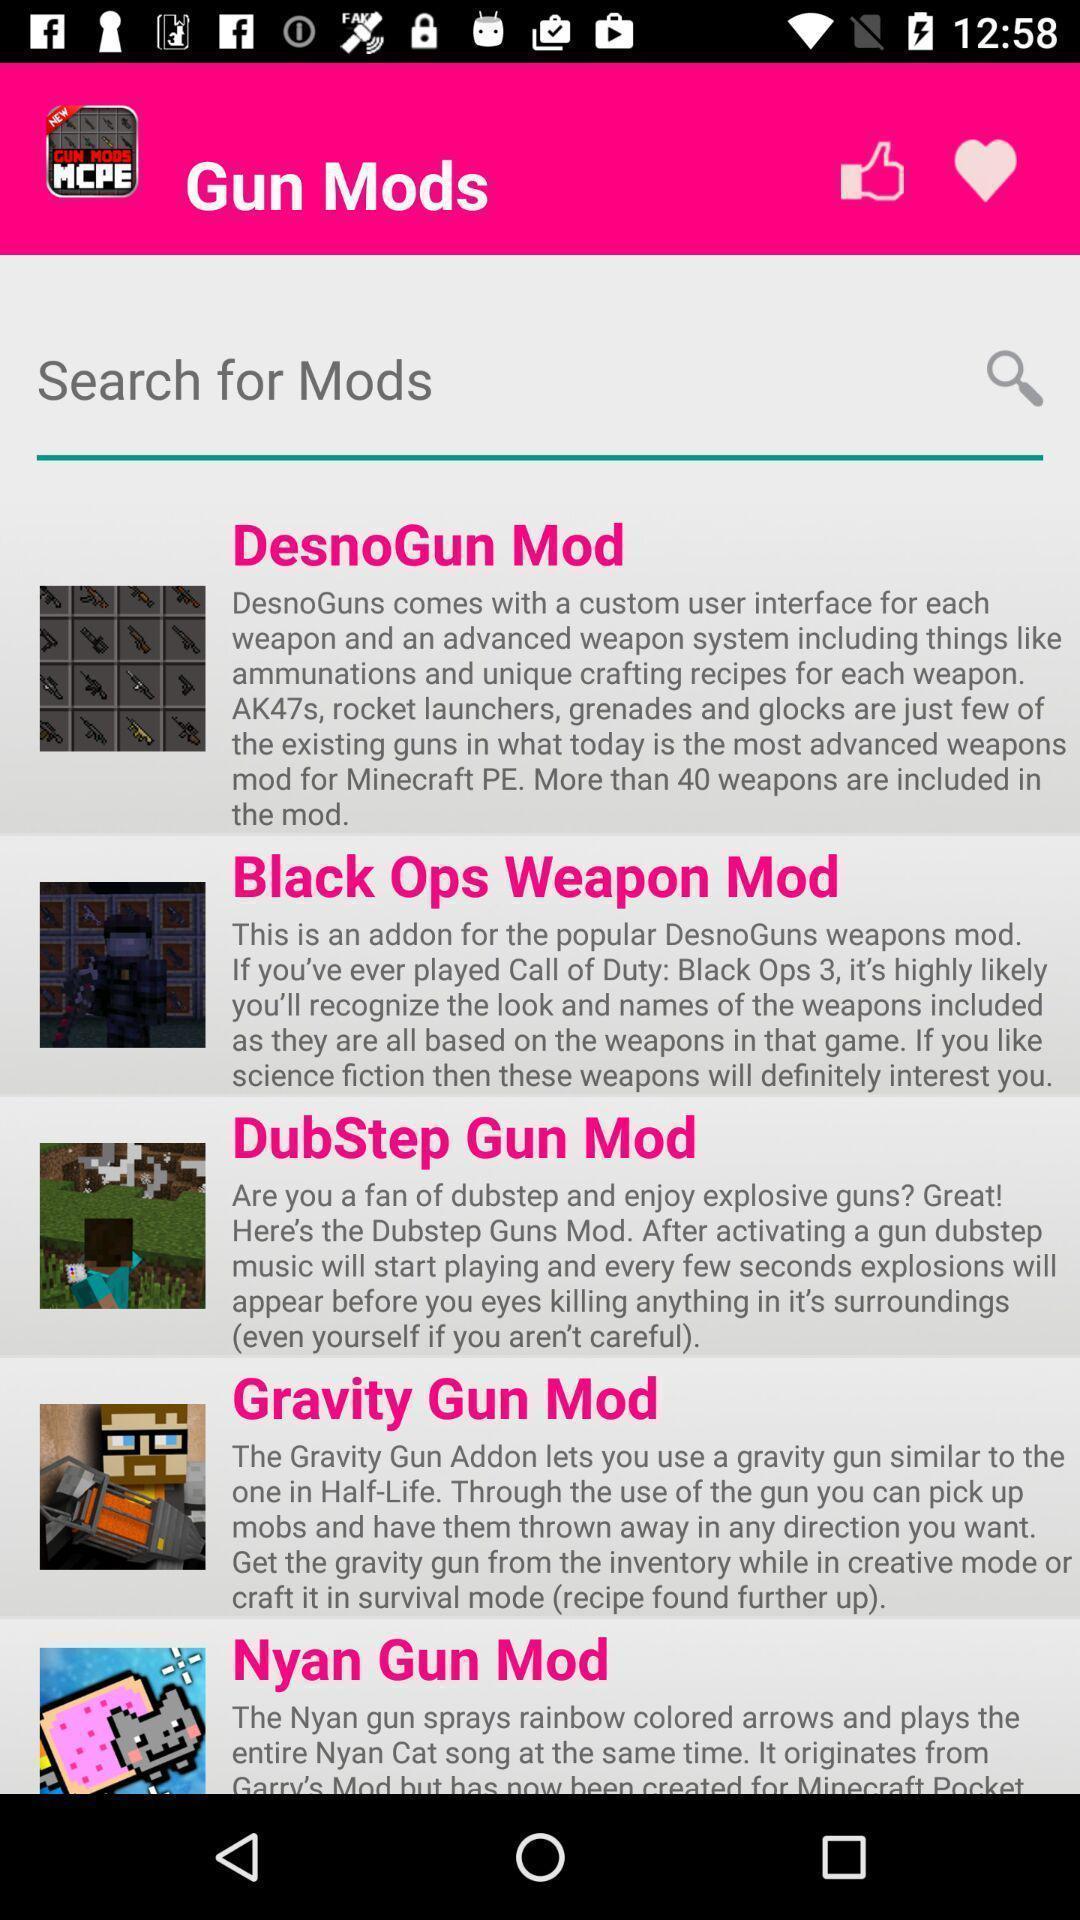Tell me what you see in this picture. Screen shows list of options in a gaming app. 